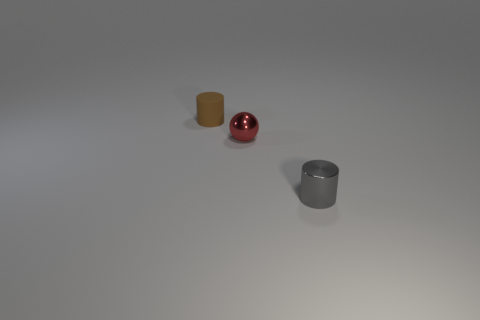Is there any other thing that has the same shape as the small red shiny object?
Your answer should be very brief. No. Are there any objects left of the red metal thing?
Give a very brief answer. Yes. What number of things are either metallic things on the left side of the tiny gray shiny cylinder or small gray metal things?
Your response must be concise. 2. The thing that is to the left of the gray shiny cylinder and in front of the brown thing is what color?
Give a very brief answer. Red. What number of objects are either objects left of the tiny gray shiny cylinder or cylinders on the right side of the small brown rubber object?
Give a very brief answer. 3. What color is the small cylinder that is in front of the metallic object that is behind the tiny cylinder in front of the brown cylinder?
Keep it short and to the point. Gray. Are there any gray metal things of the same shape as the small brown matte thing?
Provide a short and direct response. Yes. How many tiny red shiny things are there?
Give a very brief answer. 1. There is a tiny rubber thing; what shape is it?
Your response must be concise. Cylinder. What number of gray shiny things have the same size as the metal ball?
Provide a short and direct response. 1. 